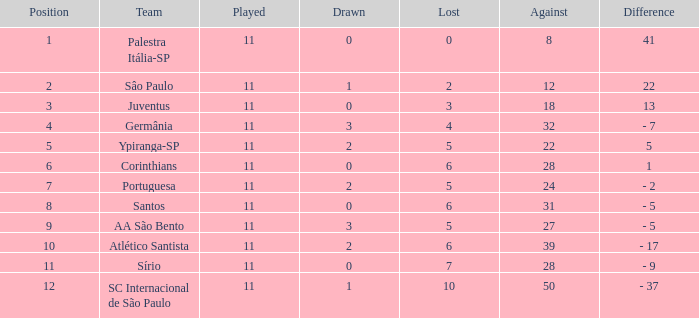What was the average Position for which the amount Drawn was less than 0? None. 